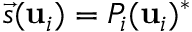<formula> <loc_0><loc_0><loc_500><loc_500>\vec { s } ( u _ { i } ) = P _ { i } ( u _ { i } ) ^ { * }</formula> 